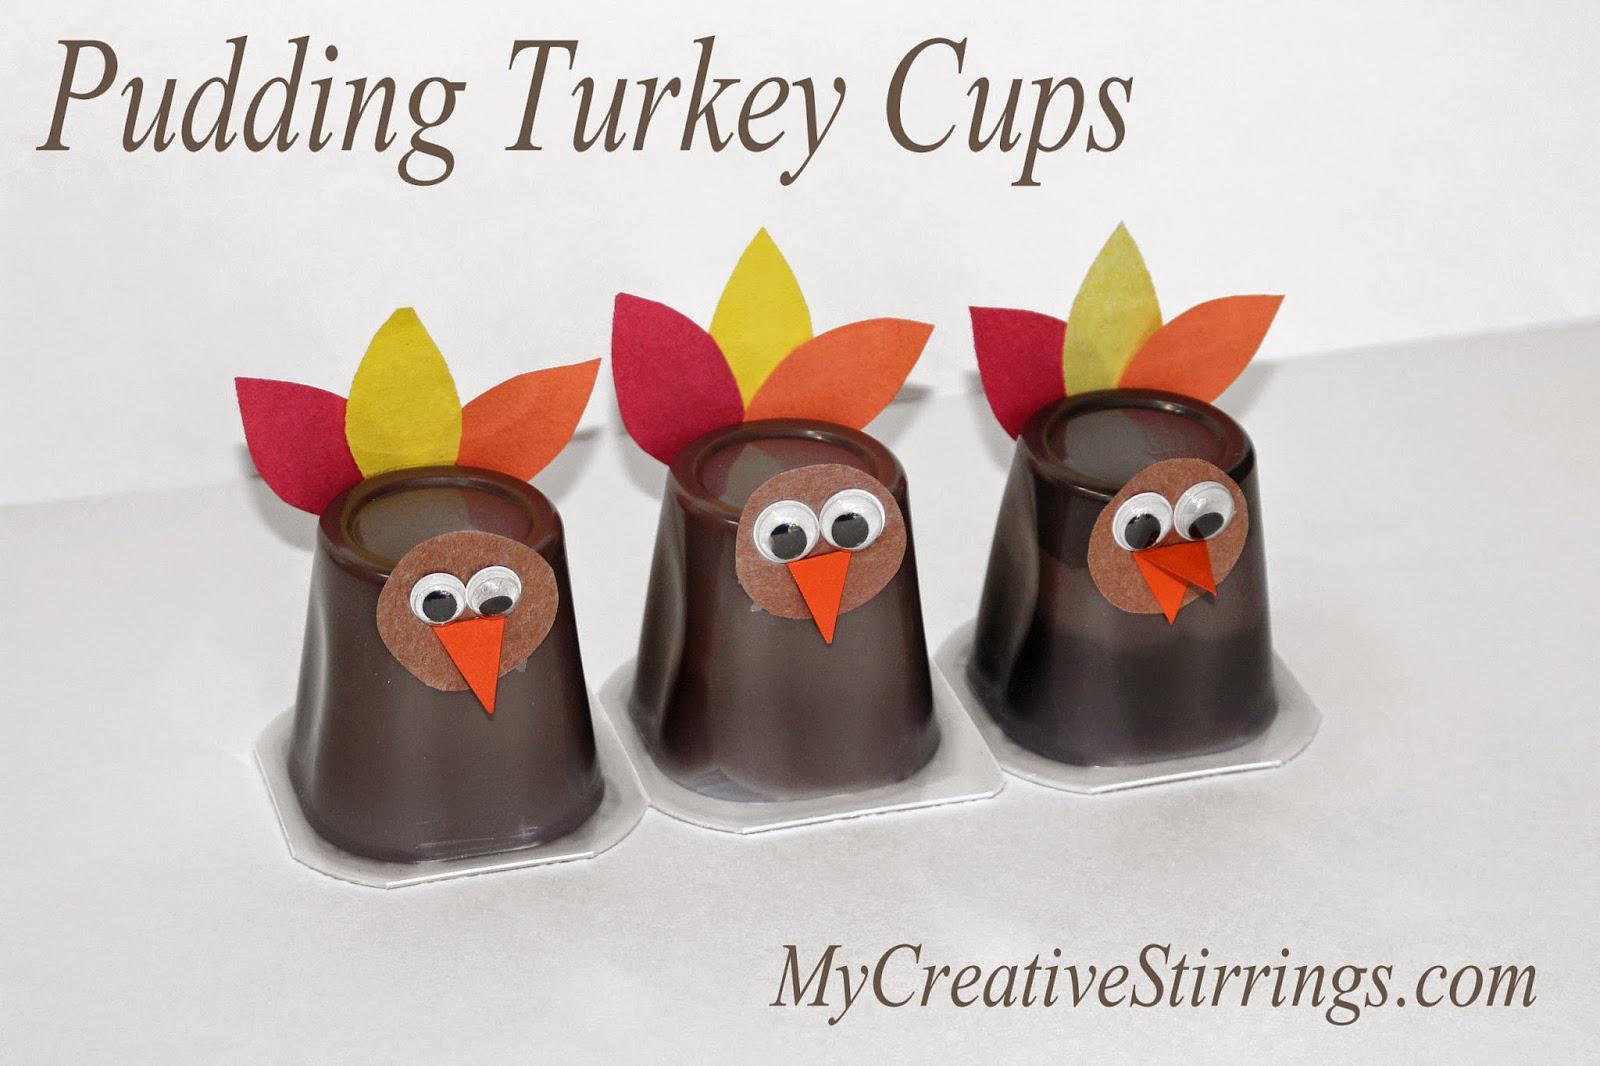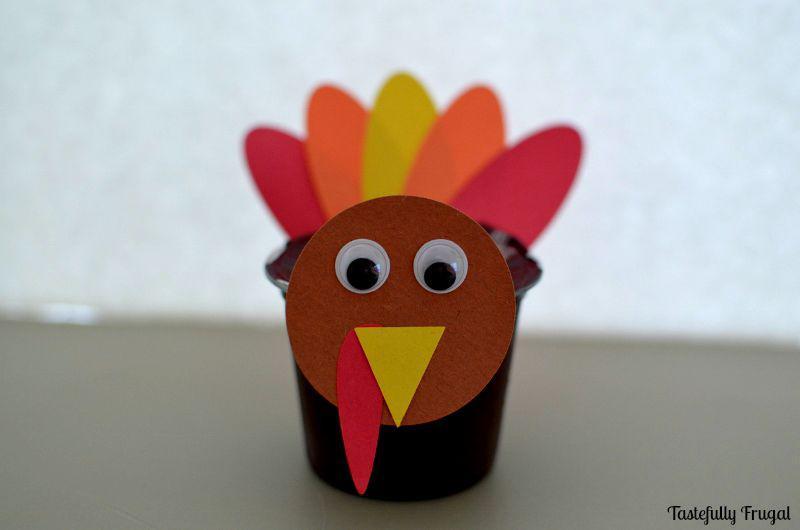The first image is the image on the left, the second image is the image on the right. For the images shown, is this caption "One image shows three pudding cup 'turkeys' that are not in a single row, and the other image includes an inverted pudding cup with a turkey face and feathers." true? Answer yes or no. No. The first image is the image on the left, the second image is the image on the right. Examine the images to the left and right. Is the description "The left and right image contains a total of four pudding cups with turkey faces." accurate? Answer yes or no. Yes. 